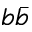<formula> <loc_0><loc_0><loc_500><loc_500>b \bar { b }</formula> 